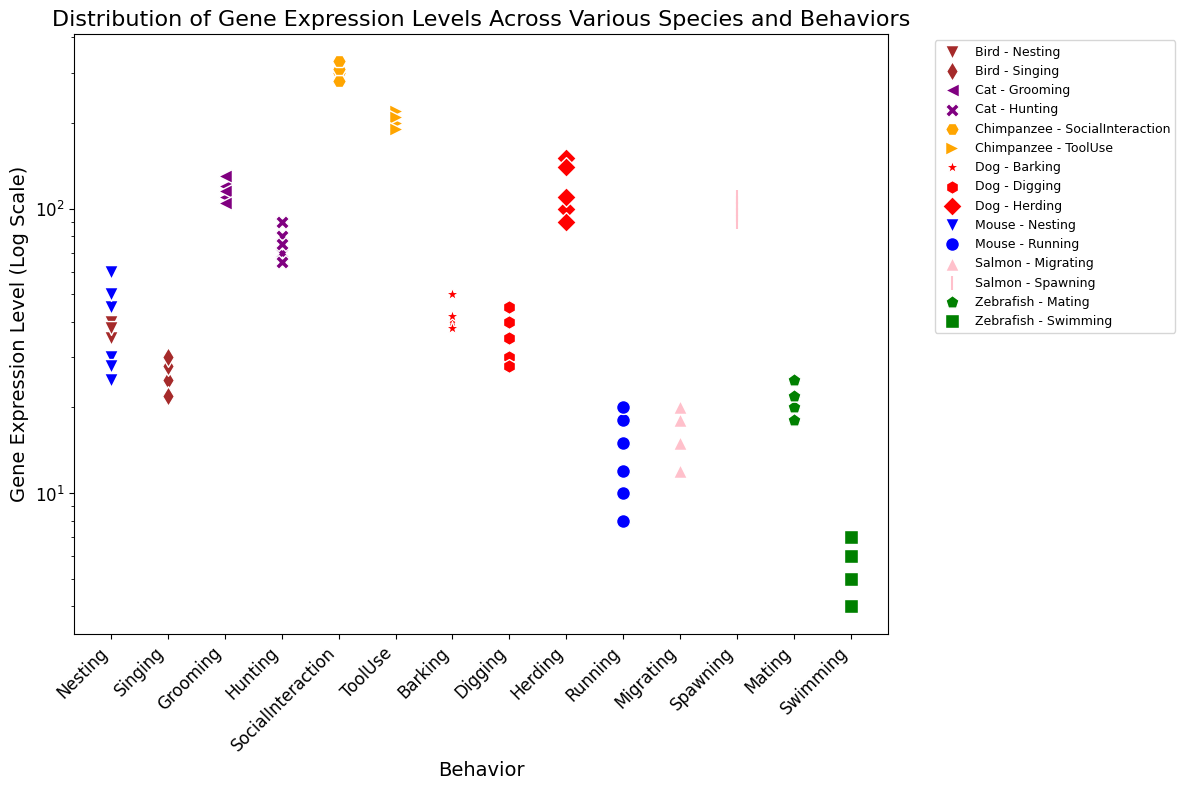what is the highest gene expression level for the "Running" behavior of the "Mouse"? To find the highest gene expression level for "Running" behavior in "Mouse," we need to look for the maximum value in the scatter points corresponding to this category in the plot.
Answer: 20 Which species and behavior combination have the lowest gene expression level? Identify the scatter point that represents the lowest value on the y-axis and check its species and behavior.
Answer: Zebrafish - Swimming How does the average gene expression level for "Nesting" behavior in "Mouse" compare to "Nesting" behavior in "Bird"? Calculate the average gene expression levels for "Nesting" in both "Mouse" and "Bird" and compare them. The gene expression levels for "Mouse" Nesting are 30, 25, 28, 45, 50, 60, averaging (30+25+28+45+50+60)/6 = 39.67. For "Bird" Nesting, they are 40, 35, 45, 50, 38, averaging (40+35+45+50+38)/5 = 41.6.
Answer: Mouse: 39.67; Bird: 41.6; Bird > Mouse What is the difference between the maximum gene expression level of "Herding" behavior in "Dog" and "Grooming" behavior in "Cat"? Using the plot, find the maximum gene expression levels for both "Herding" behavior in "Dog" and "Grooming" behavior in "Cat". For "Dog" Herding, the maximum is 150. For "Cat" Grooming, the maximum is 130. The difference is 150 - 130 = 20.
Answer: 20 Which behavior in "Chimpanzee" has a higher gene expression level, "ToolUse" or "SocialInteraction"? Compare the gene expression levels for "ToolUse" and "SocialInteraction" in "Chimpanzee" from the plot. The gene expression levels for "ToolUse" are 200, 220, 210, 190, averaging to (200 + 220 + 210 + 190)/4 = 205. For "SocialInteraction", they are 300, 280, 310, 330, averaging to (300 + 280 + 310 + 330)/4 = 305.
Answer: SocialInteraction How does the distribution of gene expression levels for "Swimming" in "Zebrafish" compare to "Running" behavior in "Mouse" in terms of variability? Assess the spread of the gene expression levels visually from the plot for both behaviors by noting the range and spread of points. "Swimming" in "Zebrafish" ranges from 4 to 7 (low variability), whereas "Running" in "Mouse" ranges from 8 to 20 (higher variability).
Answer: Mouse - Running has higher variability What is the median gene expression level for "Spawning" behavior in "Salmon"? For "Spawning" in "Salmon," the gene expression levels are 100, 90, 95, 110, 105. Arrange them in order: 90, 95, 100, 105, 110. The median is the middle value, 100.
Answer: 100 Is the gene expression level for "Hunting" behavior in "Cat" generally higher than for "Barking" behavior in "Dog"? Compare the central tendency of the scatter points for "Cat - Hunting" and "Dog - Barking." "Hunting" in "Cat" has levels between 65 and 90, while "Barking" in "Dog" has levels between 38 and 50. This suggests "Hunting" levels are generally higher.
Answer: Yes 